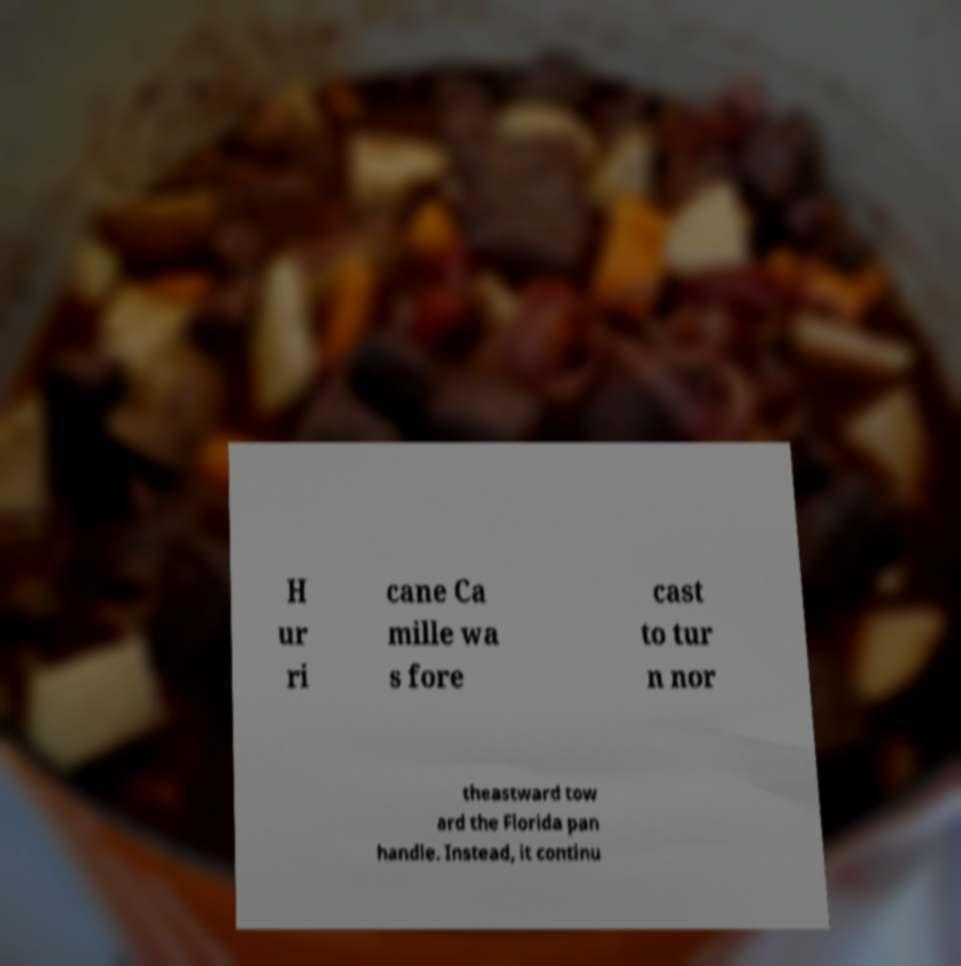What messages or text are displayed in this image? I need them in a readable, typed format. H ur ri cane Ca mille wa s fore cast to tur n nor theastward tow ard the Florida pan handle. Instead, it continu 